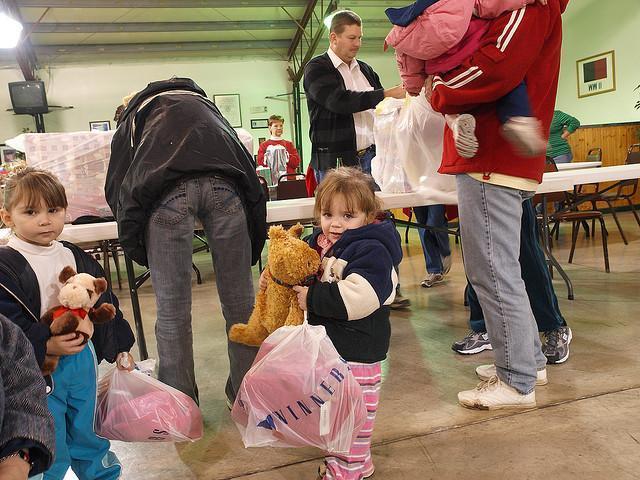How many people are there?
Give a very brief answer. 9. How many teddy bears are in the picture?
Give a very brief answer. 2. 